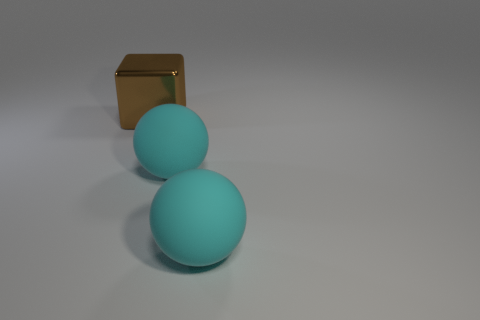Add 1 big cyan spheres. How many objects exist? 4 Subtract all balls. How many objects are left? 1 Subtract all rubber cubes. Subtract all large spheres. How many objects are left? 1 Add 3 cyan spheres. How many cyan spheres are left? 5 Add 2 gray rubber things. How many gray rubber things exist? 2 Subtract 1 brown blocks. How many objects are left? 2 